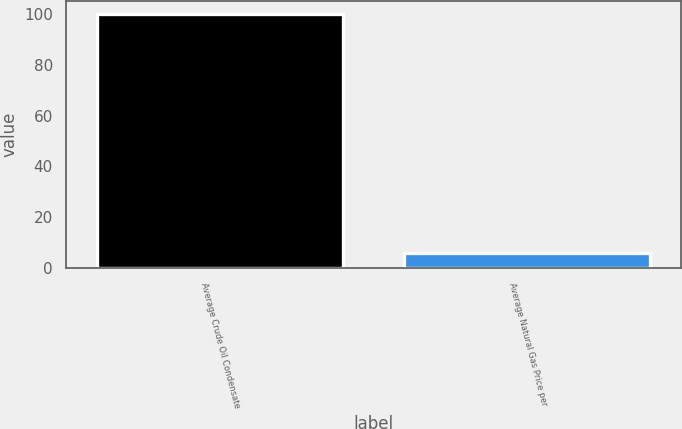Convert chart to OTSL. <chart><loc_0><loc_0><loc_500><loc_500><bar_chart><fcel>Average Crude Oil Condensate<fcel>Average Natural Gas Price per<nl><fcel>99.92<fcel>5.85<nl></chart> 